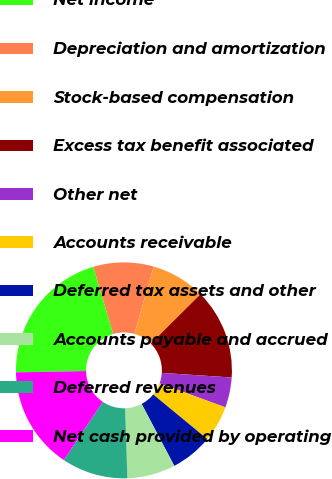Convert chart. <chart><loc_0><loc_0><loc_500><loc_500><pie_chart><fcel>Net income<fcel>Depreciation and amortization<fcel>Stock-based compensation<fcel>Excess tax benefit associated<fcel>Other net<fcel>Accounts receivable<fcel>Deferred tax assets and other<fcel>Accounts payable and accrued<fcel>Deferred revenues<fcel>Net cash provided by operating<nl><fcel>20.72%<fcel>9.01%<fcel>8.11%<fcel>13.51%<fcel>4.51%<fcel>5.41%<fcel>6.31%<fcel>7.21%<fcel>9.91%<fcel>15.31%<nl></chart> 